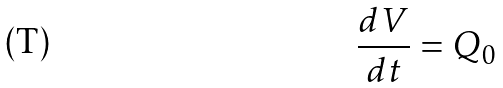<formula> <loc_0><loc_0><loc_500><loc_500>\frac { d V } { d t } = Q _ { 0 }</formula> 